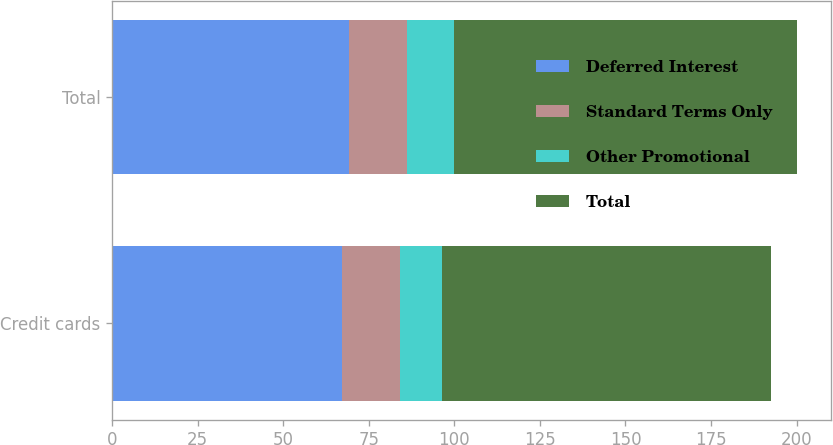Convert chart. <chart><loc_0><loc_0><loc_500><loc_500><stacked_bar_chart><ecel><fcel>Credit cards<fcel>Total<nl><fcel>Deferred Interest<fcel>67.1<fcel>69.1<nl><fcel>Standard Terms Only<fcel>17.1<fcel>17.1<nl><fcel>Other Promotional<fcel>12.1<fcel>13.8<nl><fcel>Total<fcel>96.3<fcel>100<nl></chart> 